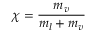Convert formula to latex. <formula><loc_0><loc_0><loc_500><loc_500>\chi = { \frac { m _ { v } } { m _ { l } + m _ { v } } }</formula> 